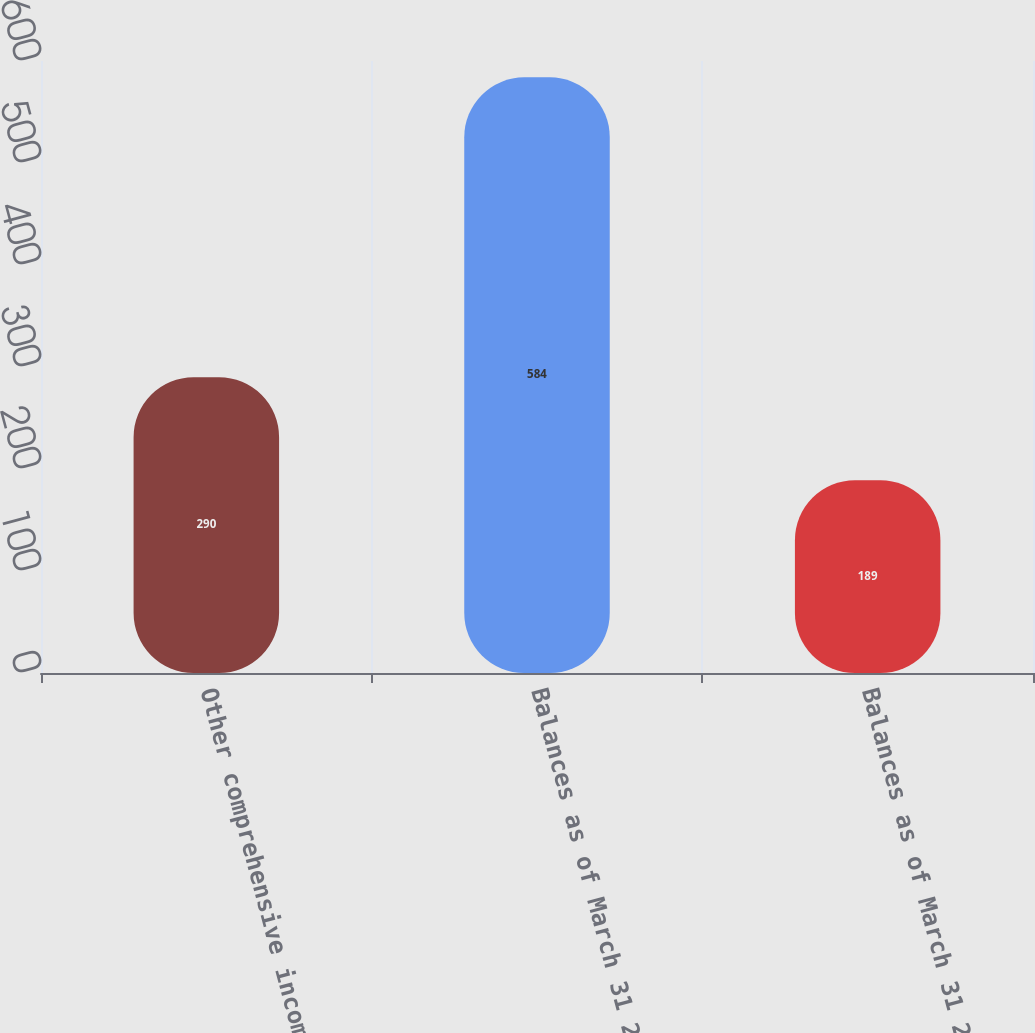Convert chart. <chart><loc_0><loc_0><loc_500><loc_500><bar_chart><fcel>Other comprehensive income<fcel>Balances as of March 31 2008<fcel>Balances as of March 31 2009<nl><fcel>290<fcel>584<fcel>189<nl></chart> 